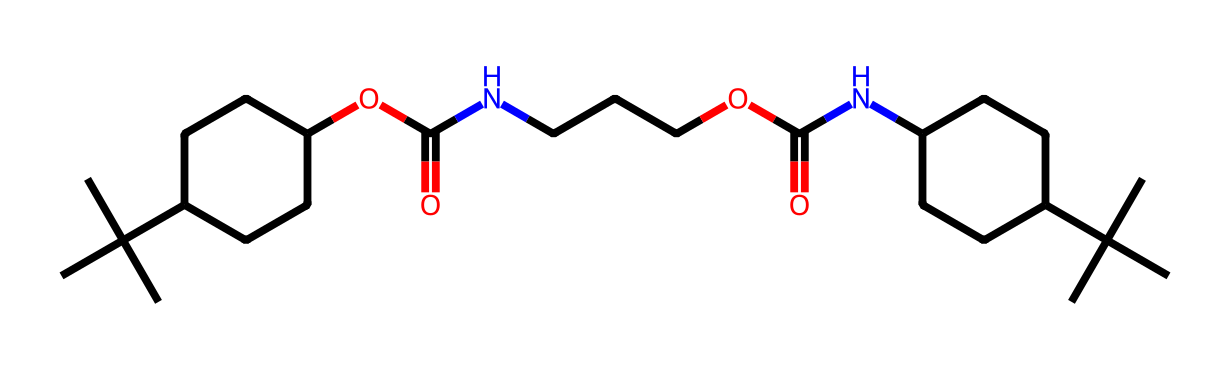What is the primary functional group present in this polymer? The chemical structure contains amide (NC) and ester (OC(=O)) groups, which are characteristic of polyurethanes. The presence of these functional groups suggests that the polymer is formed through polyaddition reactions.
Answer: amide and ester How many carbon atoms are in the chemical structure? By counting the carbon atoms in the SMILES representation, I find a total of 19 carbon atoms present in the entire molecule.
Answer: 19 What is the total number of nitrogen atoms in this polymer? In the provided chemical structure, there are two occurrences of nitrogen (N) in the amide groups, totaling to two nitrogen atoms in the polymer backbone.
Answer: 2 What type of polymer is represented by this chemical structure? This chemical structure represents a polyurethane because it is formed by the reaction of polyols and isocyanates, and contains both urethane linkages and a polymeric backbone.
Answer: polyurethane How many oxygen atoms are present in this polymer? The chemical structure includes four oxygen atoms; two are from the ester groups and two are from the amide groups. A quick count reveals these four oxygen atoms in the entire structure.
Answer: 4 What is the significance of the branched alkyl groups in the structure? The branched alkyl groups (CC(C)(C)) increase the chain flexibility, reduce the density, and improve thermal insulation properties of the polyurethane foam, which is crucial for Arctic conditions.
Answer: flexibility 